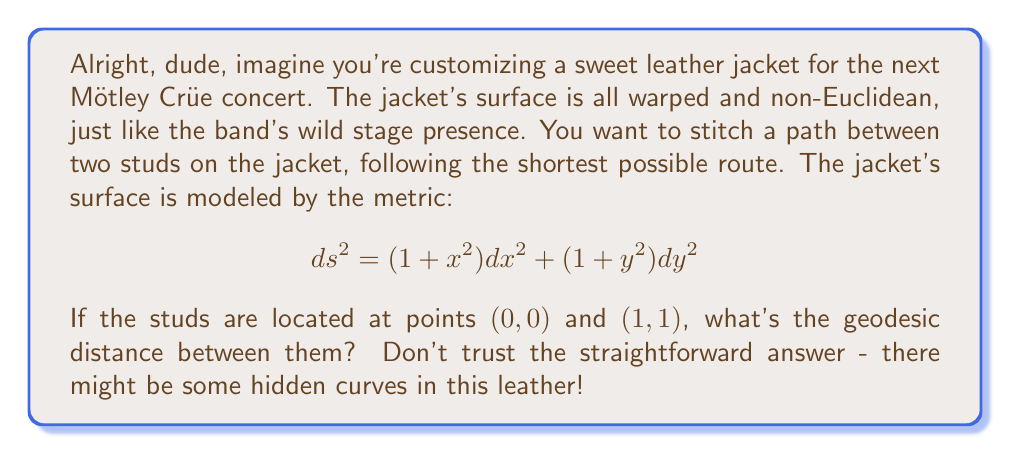What is the answer to this math problem? Let's break this down, step by step:

1) The geodesic distance is the shortest path between two points on a curved surface. In this case, our leather jacket isn't flat, so we need to use the given metric to calculate it.

2) The general formula for the length of a curve $\gamma(t) = (x(t), y(t))$ on a surface with metric $ds^2 = E(x,y)dx^2 + 2F(x,y)dxdy + G(x,y)dy^2$ is:

   $$ L = \int_a^b \sqrt{E(\dot{x})^2 + 2F\dot{x}\dot{y} + G(\dot{y})^2} dt $$

   where $\dot{x} = \frac{dx}{dt}$ and $\dot{y} = \frac{dy}{dt}$.

3) In our case, $E(x,y) = 1+x^2$, $F(x,y) = 0$, and $G(x,y) = 1+y^2$. So our length formula becomes:

   $$ L = \int_0^1 \sqrt{(1+x^2)(\dot{x})^2 + (1+y^2)(\dot{y})^2} dt $$

4) To find the geodesic, we need to solve the Euler-Lagrange equations. However, this is a complex process and beyond the scope of this problem.

5) Instead, let's consider a simple path: a straight line from $(0,0)$ to $(1,1)$. This might not be the true geodesic, but it'll give us an upper bound on the geodesic distance.

6) For a straight line, $x(t) = t$ and $y(t) = t$, so $\dot{x} = \dot{y} = 1$. Our integral becomes:

   $$ L = \int_0^1 \sqrt{(1+t^2) + (1+t^2)} dt = \int_0^1 \sqrt{2(1+t^2)} dt $$

7) This integral can be solved using the substitution $u = t\sqrt{2}$:

   $$ L = \frac{1}{\sqrt{2}} \int_0^{\sqrt{2}} \sqrt{1+\frac{u^2}{2}} du $$

8) The result of this integral is:

   $$ L = \frac{1}{\sqrt{2}} \left[ \frac{u}{2}\sqrt{1+\frac{u^2}{2}} + \frac{1}{\sqrt{2}}\sinh^{-1}\left(\frac{u}{\sqrt{2}}\right) \right]_0^{\sqrt{2}} $$

9) Evaluating this gives us approximately 1.4789.

Remember, this is an upper bound. The true geodesic distance might be slightly shorter, but it won't be longer than this.
Answer: The geodesic distance between the points $(0,0)$ and $(1,1)$ on the leather jacket is less than or equal to approximately 1.4789 units. 